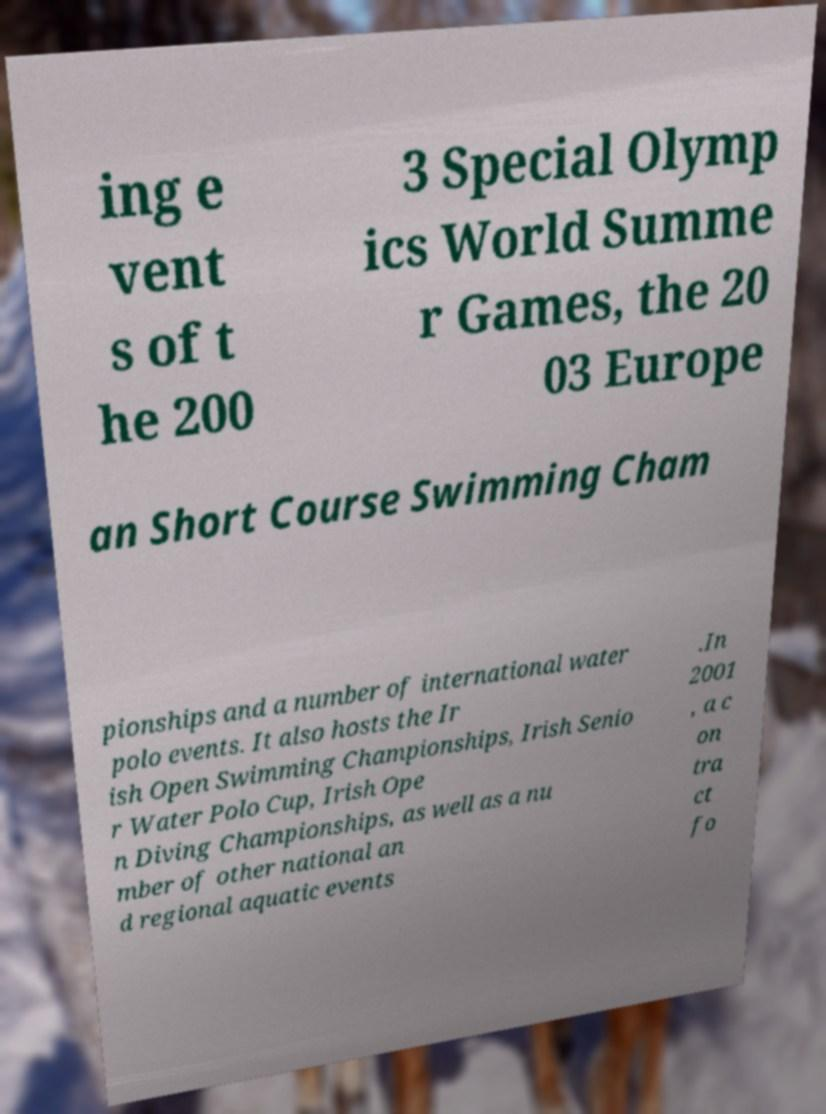Please read and relay the text visible in this image. What does it say? ing e vent s of t he 200 3 Special Olymp ics World Summe r Games, the 20 03 Europe an Short Course Swimming Cham pionships and a number of international water polo events. It also hosts the Ir ish Open Swimming Championships, Irish Senio r Water Polo Cup, Irish Ope n Diving Championships, as well as a nu mber of other national an d regional aquatic events .In 2001 , a c on tra ct fo 